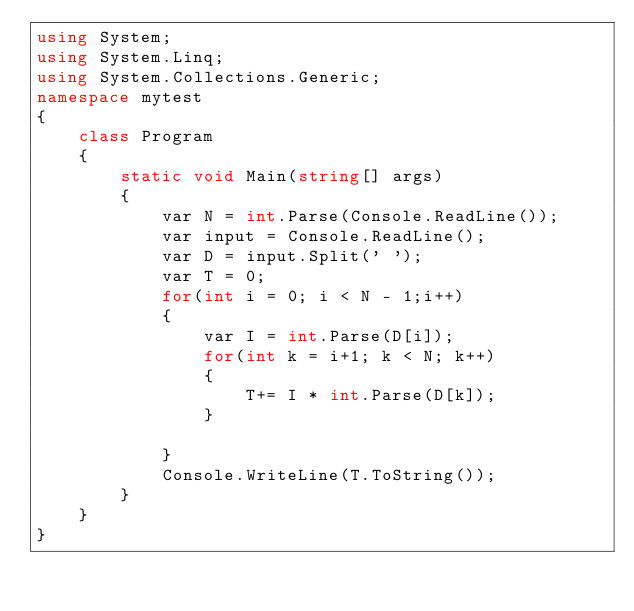<code> <loc_0><loc_0><loc_500><loc_500><_C#_>using System;
using System.Linq;
using System.Collections.Generic;
namespace mytest
{
    class Program
    {
        static void Main(string[] args)
        {
            var N = int.Parse(Console.ReadLine());
            var input = Console.ReadLine();            
            var D = input.Split(' ');
            var T = 0;
            for(int i = 0; i < N - 1;i++)
            {
                var I = int.Parse(D[i]);
                for(int k = i+1; k < N; k++)
                {
                    T+= I * int.Parse(D[k]);
                }

            }
            Console.WriteLine(T.ToString());
        }
    }
}
</code> 